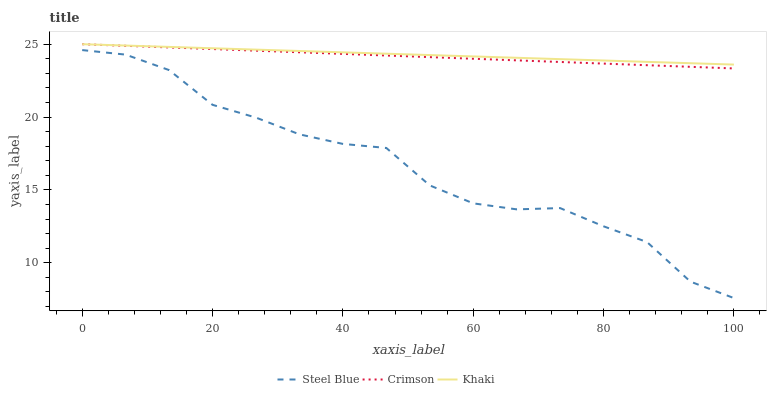Does Steel Blue have the minimum area under the curve?
Answer yes or no. Yes. Does Khaki have the maximum area under the curve?
Answer yes or no. Yes. Does Khaki have the minimum area under the curve?
Answer yes or no. No. Does Steel Blue have the maximum area under the curve?
Answer yes or no. No. Is Khaki the smoothest?
Answer yes or no. Yes. Is Steel Blue the roughest?
Answer yes or no. Yes. Is Steel Blue the smoothest?
Answer yes or no. No. Is Khaki the roughest?
Answer yes or no. No. Does Steel Blue have the lowest value?
Answer yes or no. Yes. Does Khaki have the lowest value?
Answer yes or no. No. Does Khaki have the highest value?
Answer yes or no. Yes. Does Steel Blue have the highest value?
Answer yes or no. No. Is Steel Blue less than Crimson?
Answer yes or no. Yes. Is Khaki greater than Steel Blue?
Answer yes or no. Yes. Does Khaki intersect Crimson?
Answer yes or no. Yes. Is Khaki less than Crimson?
Answer yes or no. No. Is Khaki greater than Crimson?
Answer yes or no. No. Does Steel Blue intersect Crimson?
Answer yes or no. No. 